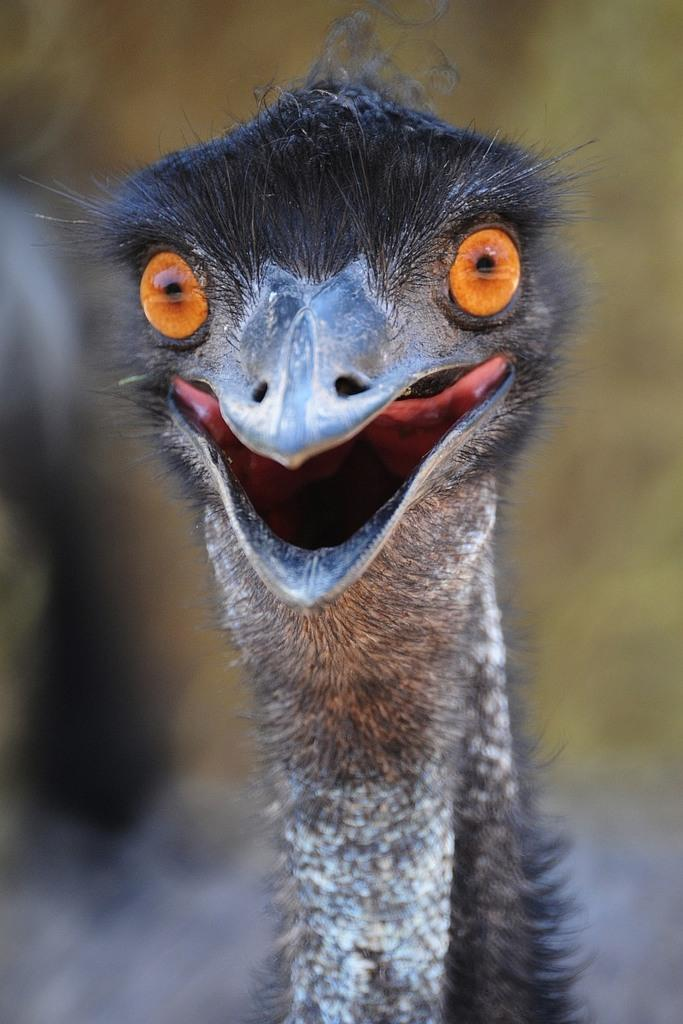What type of animal is in the picture? There is an emu bird in the picture. What is a distinctive feature of the emu bird? The emu bird has a long neck. Can you describe the background of the image? The background of the image is blurred. Where might this picture have been taken? The picture might have been taken in a zoo. What emotion does the emu bird display in the picture? The emu bird does not display emotions in the picture, as it is a bird and not capable of expressing emotions like humans. --- Facts: 1. There is a person holding a camera in the image. 2. The person is wearing a hat. 3. The background of the image is a cityscape. 4. The person is standing on a bridge. Absurd Topics: dance, swim, mountain Conversation: What is the person in the image doing? The person in the image is holding a camera. Can you describe the person's attire? The person is wearing a hat. What can be seen in the background of the image? The background of the image is a cityscape. Where is the person standing in the image? The person is standing on a bridge. Reasoning: Let's think step by step in order to produce the conversation. We start by identifying the main subject in the image, which is the person holding a camera. Then, we describe the person's attire, noting that they are wearing a hat. Next, we mention the background of the image, which is a cityscape. Finally, we specify the location where the person is standing, which is on a bridge. Absurd Question/Answer: Can you tell me how the person is dancing in the image? There is no dancing depicted in the image; the person is holding a camera and standing on a bridge. 